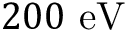<formula> <loc_0><loc_0><loc_500><loc_500>2 0 0 e V</formula> 